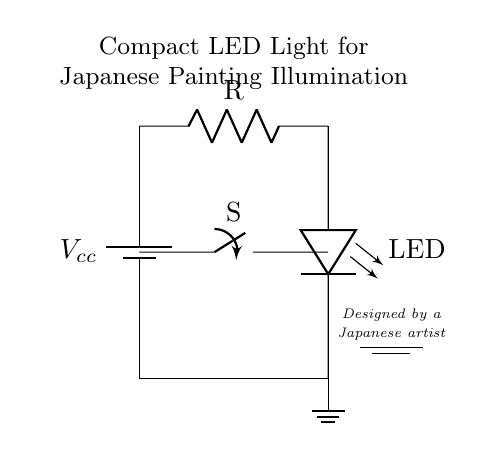What is the power supply component in this circuit? The power supply component in the circuit is represented by a battery, indicated by its symbol on the left side of the diagram.
Answer: Battery What type of light source is used in this circuit? The circuit uses an LED, which is specified as 'LED' in the diagram where it is connected to the resistor.
Answer: LED What is the role of the switch in this circuit? The switch allows for controlling the flow of current in the circuit; when closed, it completes the circuit and turns on the LED.
Answer: Control How many resistors are present in this circuit? There is one resistor shown in the circuit, labeled simply as 'R', between the battery and the LED.
Answer: One What is the function of the resistor in this circuit? The resistor limits the current flowing through the LED, protecting it from excess current that could damage it.
Answer: Limit current What is the voltage symbol indicated in the circuit diagram? The voltage symbol indicated in the circuit is Vcc, which represents the supply voltage connected to the circuit.
Answer: Vcc What artistic touch is included in this circuit diagram? The circuit diagram includes a note stating it was designed by a Japanese artist, which adds a personal and artistic element to the schematic.
Answer: Japanese artist 